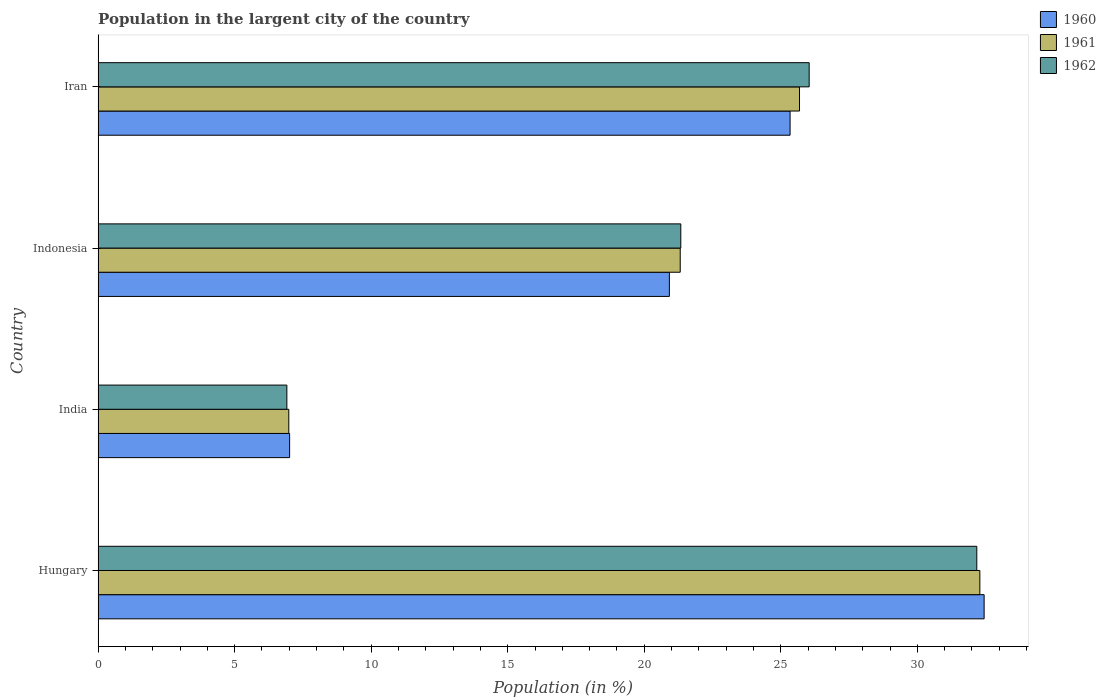How many groups of bars are there?
Your response must be concise. 4. Are the number of bars on each tick of the Y-axis equal?
Ensure brevity in your answer.  Yes. How many bars are there on the 2nd tick from the top?
Keep it short and to the point. 3. What is the percentage of population in the largent city in 1960 in Indonesia?
Your answer should be compact. 20.92. Across all countries, what is the maximum percentage of population in the largent city in 1962?
Your response must be concise. 32.18. Across all countries, what is the minimum percentage of population in the largent city in 1962?
Offer a terse response. 6.91. In which country was the percentage of population in the largent city in 1961 maximum?
Ensure brevity in your answer.  Hungary. What is the total percentage of population in the largent city in 1961 in the graph?
Your answer should be compact. 86.27. What is the difference between the percentage of population in the largent city in 1961 in India and that in Iran?
Offer a terse response. -18.7. What is the difference between the percentage of population in the largent city in 1960 in India and the percentage of population in the largent city in 1962 in Indonesia?
Your answer should be compact. -14.32. What is the average percentage of population in the largent city in 1960 per country?
Your answer should be compact. 21.43. What is the difference between the percentage of population in the largent city in 1961 and percentage of population in the largent city in 1962 in India?
Keep it short and to the point. 0.07. What is the ratio of the percentage of population in the largent city in 1960 in Hungary to that in Iran?
Give a very brief answer. 1.28. Is the difference between the percentage of population in the largent city in 1961 in India and Iran greater than the difference between the percentage of population in the largent city in 1962 in India and Iran?
Offer a very short reply. Yes. What is the difference between the highest and the second highest percentage of population in the largent city in 1962?
Your answer should be compact. 6.14. What is the difference between the highest and the lowest percentage of population in the largent city in 1962?
Offer a very short reply. 25.27. Is the sum of the percentage of population in the largent city in 1962 in Hungary and Indonesia greater than the maximum percentage of population in the largent city in 1960 across all countries?
Keep it short and to the point. Yes. What does the 3rd bar from the top in Indonesia represents?
Provide a succinct answer. 1960. What does the 1st bar from the bottom in India represents?
Keep it short and to the point. 1960. Are all the bars in the graph horizontal?
Offer a very short reply. Yes. How many countries are there in the graph?
Provide a short and direct response. 4. What is the difference between two consecutive major ticks on the X-axis?
Offer a terse response. 5. Does the graph contain grids?
Your answer should be compact. No. Where does the legend appear in the graph?
Your answer should be very brief. Top right. What is the title of the graph?
Your answer should be compact. Population in the largent city of the country. Does "1974" appear as one of the legend labels in the graph?
Your answer should be very brief. No. What is the label or title of the Y-axis?
Your answer should be very brief. Country. What is the Population (in %) of 1960 in Hungary?
Keep it short and to the point. 32.44. What is the Population (in %) of 1961 in Hungary?
Offer a terse response. 32.29. What is the Population (in %) of 1962 in Hungary?
Ensure brevity in your answer.  32.18. What is the Population (in %) of 1960 in India?
Provide a short and direct response. 7.01. What is the Population (in %) in 1961 in India?
Make the answer very short. 6.98. What is the Population (in %) in 1962 in India?
Make the answer very short. 6.91. What is the Population (in %) in 1960 in Indonesia?
Provide a succinct answer. 20.92. What is the Population (in %) in 1961 in Indonesia?
Keep it short and to the point. 21.32. What is the Population (in %) in 1962 in Indonesia?
Ensure brevity in your answer.  21.34. What is the Population (in %) of 1960 in Iran?
Give a very brief answer. 25.34. What is the Population (in %) of 1961 in Iran?
Your answer should be compact. 25.68. What is the Population (in %) of 1962 in Iran?
Your response must be concise. 26.04. Across all countries, what is the maximum Population (in %) of 1960?
Ensure brevity in your answer.  32.44. Across all countries, what is the maximum Population (in %) of 1961?
Ensure brevity in your answer.  32.29. Across all countries, what is the maximum Population (in %) of 1962?
Ensure brevity in your answer.  32.18. Across all countries, what is the minimum Population (in %) of 1960?
Your answer should be very brief. 7.01. Across all countries, what is the minimum Population (in %) of 1961?
Your answer should be very brief. 6.98. Across all countries, what is the minimum Population (in %) in 1962?
Ensure brevity in your answer.  6.91. What is the total Population (in %) in 1960 in the graph?
Your response must be concise. 85.72. What is the total Population (in %) of 1961 in the graph?
Offer a very short reply. 86.27. What is the total Population (in %) in 1962 in the graph?
Offer a very short reply. 86.46. What is the difference between the Population (in %) of 1960 in Hungary and that in India?
Your answer should be very brief. 25.43. What is the difference between the Population (in %) of 1961 in Hungary and that in India?
Provide a short and direct response. 25.31. What is the difference between the Population (in %) in 1962 in Hungary and that in India?
Your response must be concise. 25.27. What is the difference between the Population (in %) in 1960 in Hungary and that in Indonesia?
Make the answer very short. 11.53. What is the difference between the Population (in %) of 1961 in Hungary and that in Indonesia?
Your answer should be compact. 10.97. What is the difference between the Population (in %) in 1962 in Hungary and that in Indonesia?
Your response must be concise. 10.84. What is the difference between the Population (in %) in 1960 in Hungary and that in Iran?
Keep it short and to the point. 7.11. What is the difference between the Population (in %) in 1961 in Hungary and that in Iran?
Your answer should be very brief. 6.6. What is the difference between the Population (in %) in 1962 in Hungary and that in Iran?
Ensure brevity in your answer.  6.14. What is the difference between the Population (in %) in 1960 in India and that in Indonesia?
Make the answer very short. -13.91. What is the difference between the Population (in %) of 1961 in India and that in Indonesia?
Your answer should be compact. -14.33. What is the difference between the Population (in %) in 1962 in India and that in Indonesia?
Your answer should be very brief. -14.43. What is the difference between the Population (in %) of 1960 in India and that in Iran?
Your response must be concise. -18.33. What is the difference between the Population (in %) in 1961 in India and that in Iran?
Offer a very short reply. -18.7. What is the difference between the Population (in %) of 1962 in India and that in Iran?
Offer a very short reply. -19.13. What is the difference between the Population (in %) of 1960 in Indonesia and that in Iran?
Keep it short and to the point. -4.42. What is the difference between the Population (in %) in 1961 in Indonesia and that in Iran?
Offer a very short reply. -4.37. What is the difference between the Population (in %) in 1962 in Indonesia and that in Iran?
Provide a succinct answer. -4.7. What is the difference between the Population (in %) of 1960 in Hungary and the Population (in %) of 1961 in India?
Make the answer very short. 25.46. What is the difference between the Population (in %) in 1960 in Hungary and the Population (in %) in 1962 in India?
Give a very brief answer. 25.53. What is the difference between the Population (in %) of 1961 in Hungary and the Population (in %) of 1962 in India?
Ensure brevity in your answer.  25.38. What is the difference between the Population (in %) of 1960 in Hungary and the Population (in %) of 1961 in Indonesia?
Make the answer very short. 11.13. What is the difference between the Population (in %) in 1960 in Hungary and the Population (in %) in 1962 in Indonesia?
Offer a very short reply. 11.11. What is the difference between the Population (in %) in 1961 in Hungary and the Population (in %) in 1962 in Indonesia?
Your response must be concise. 10.95. What is the difference between the Population (in %) of 1960 in Hungary and the Population (in %) of 1961 in Iran?
Offer a terse response. 6.76. What is the difference between the Population (in %) in 1960 in Hungary and the Population (in %) in 1962 in Iran?
Provide a succinct answer. 6.41. What is the difference between the Population (in %) in 1961 in Hungary and the Population (in %) in 1962 in Iran?
Your answer should be compact. 6.25. What is the difference between the Population (in %) in 1960 in India and the Population (in %) in 1961 in Indonesia?
Give a very brief answer. -14.3. What is the difference between the Population (in %) of 1960 in India and the Population (in %) of 1962 in Indonesia?
Offer a terse response. -14.32. What is the difference between the Population (in %) in 1961 in India and the Population (in %) in 1962 in Indonesia?
Make the answer very short. -14.35. What is the difference between the Population (in %) of 1960 in India and the Population (in %) of 1961 in Iran?
Make the answer very short. -18.67. What is the difference between the Population (in %) in 1960 in India and the Population (in %) in 1962 in Iran?
Your response must be concise. -19.02. What is the difference between the Population (in %) of 1961 in India and the Population (in %) of 1962 in Iran?
Your answer should be very brief. -19.06. What is the difference between the Population (in %) in 1960 in Indonesia and the Population (in %) in 1961 in Iran?
Make the answer very short. -4.77. What is the difference between the Population (in %) of 1960 in Indonesia and the Population (in %) of 1962 in Iran?
Make the answer very short. -5.12. What is the difference between the Population (in %) in 1961 in Indonesia and the Population (in %) in 1962 in Iran?
Keep it short and to the point. -4.72. What is the average Population (in %) in 1960 per country?
Provide a short and direct response. 21.43. What is the average Population (in %) in 1961 per country?
Provide a succinct answer. 21.57. What is the average Population (in %) of 1962 per country?
Make the answer very short. 21.62. What is the difference between the Population (in %) in 1960 and Population (in %) in 1961 in Hungary?
Give a very brief answer. 0.16. What is the difference between the Population (in %) of 1960 and Population (in %) of 1962 in Hungary?
Make the answer very short. 0.27. What is the difference between the Population (in %) of 1961 and Population (in %) of 1962 in Hungary?
Make the answer very short. 0.11. What is the difference between the Population (in %) of 1960 and Population (in %) of 1961 in India?
Provide a short and direct response. 0.03. What is the difference between the Population (in %) in 1960 and Population (in %) in 1962 in India?
Your answer should be very brief. 0.1. What is the difference between the Population (in %) of 1961 and Population (in %) of 1962 in India?
Your response must be concise. 0.07. What is the difference between the Population (in %) in 1960 and Population (in %) in 1961 in Indonesia?
Your answer should be very brief. -0.4. What is the difference between the Population (in %) of 1960 and Population (in %) of 1962 in Indonesia?
Keep it short and to the point. -0.42. What is the difference between the Population (in %) of 1961 and Population (in %) of 1962 in Indonesia?
Provide a succinct answer. -0.02. What is the difference between the Population (in %) in 1960 and Population (in %) in 1961 in Iran?
Give a very brief answer. -0.35. What is the difference between the Population (in %) of 1960 and Population (in %) of 1962 in Iran?
Offer a very short reply. -0.7. What is the difference between the Population (in %) of 1961 and Population (in %) of 1962 in Iran?
Make the answer very short. -0.35. What is the ratio of the Population (in %) of 1960 in Hungary to that in India?
Keep it short and to the point. 4.63. What is the ratio of the Population (in %) in 1961 in Hungary to that in India?
Ensure brevity in your answer.  4.62. What is the ratio of the Population (in %) in 1962 in Hungary to that in India?
Make the answer very short. 4.66. What is the ratio of the Population (in %) in 1960 in Hungary to that in Indonesia?
Your answer should be very brief. 1.55. What is the ratio of the Population (in %) of 1961 in Hungary to that in Indonesia?
Ensure brevity in your answer.  1.51. What is the ratio of the Population (in %) in 1962 in Hungary to that in Indonesia?
Keep it short and to the point. 1.51. What is the ratio of the Population (in %) of 1960 in Hungary to that in Iran?
Offer a terse response. 1.28. What is the ratio of the Population (in %) in 1961 in Hungary to that in Iran?
Ensure brevity in your answer.  1.26. What is the ratio of the Population (in %) in 1962 in Hungary to that in Iran?
Make the answer very short. 1.24. What is the ratio of the Population (in %) of 1960 in India to that in Indonesia?
Your answer should be compact. 0.34. What is the ratio of the Population (in %) of 1961 in India to that in Indonesia?
Offer a very short reply. 0.33. What is the ratio of the Population (in %) of 1962 in India to that in Indonesia?
Your response must be concise. 0.32. What is the ratio of the Population (in %) in 1960 in India to that in Iran?
Your answer should be very brief. 0.28. What is the ratio of the Population (in %) in 1961 in India to that in Iran?
Your answer should be compact. 0.27. What is the ratio of the Population (in %) in 1962 in India to that in Iran?
Your answer should be compact. 0.27. What is the ratio of the Population (in %) of 1960 in Indonesia to that in Iran?
Offer a very short reply. 0.83. What is the ratio of the Population (in %) of 1961 in Indonesia to that in Iran?
Make the answer very short. 0.83. What is the ratio of the Population (in %) of 1962 in Indonesia to that in Iran?
Offer a terse response. 0.82. What is the difference between the highest and the second highest Population (in %) in 1960?
Give a very brief answer. 7.11. What is the difference between the highest and the second highest Population (in %) in 1961?
Your response must be concise. 6.6. What is the difference between the highest and the second highest Population (in %) of 1962?
Your answer should be very brief. 6.14. What is the difference between the highest and the lowest Population (in %) of 1960?
Your response must be concise. 25.43. What is the difference between the highest and the lowest Population (in %) in 1961?
Offer a terse response. 25.31. What is the difference between the highest and the lowest Population (in %) of 1962?
Offer a terse response. 25.27. 